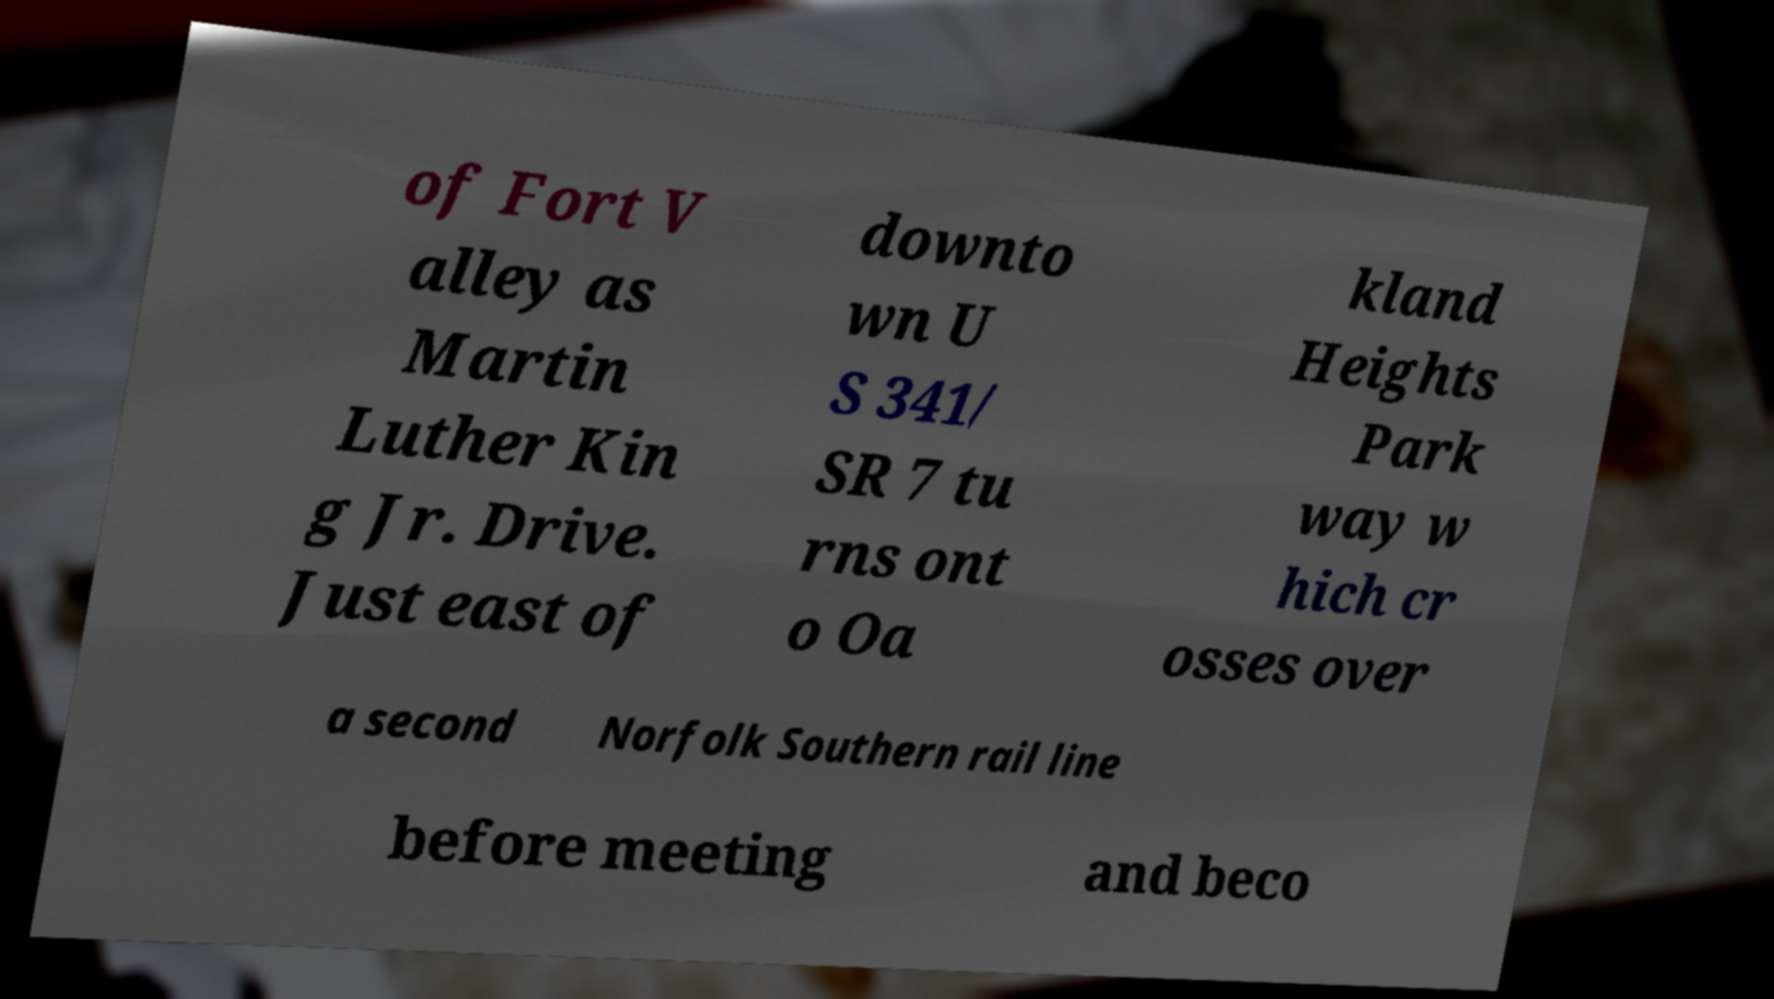There's text embedded in this image that I need extracted. Can you transcribe it verbatim? of Fort V alley as Martin Luther Kin g Jr. Drive. Just east of downto wn U S 341/ SR 7 tu rns ont o Oa kland Heights Park way w hich cr osses over a second Norfolk Southern rail line before meeting and beco 